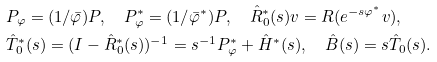Convert formula to latex. <formula><loc_0><loc_0><loc_500><loc_500>& P _ { \varphi } = ( 1 / \bar { \varphi } ) P , \quad P _ { \varphi } ^ { * } = ( 1 / \bar { \varphi } ^ { * } ) P , \quad \hat { R } _ { 0 } ^ { * } ( s ) v = R ( e ^ { - s \varphi ^ { * } } v ) , \\ & \hat { T } _ { 0 } ^ { * } ( s ) = ( I - \hat { R } _ { 0 } ^ { * } ( s ) ) ^ { - 1 } = s ^ { - 1 } P _ { \varphi } ^ { * } + \hat { H } ^ { * } ( s ) , \quad \hat { B } ( s ) = s \hat { T } _ { 0 } ( s ) .</formula> 